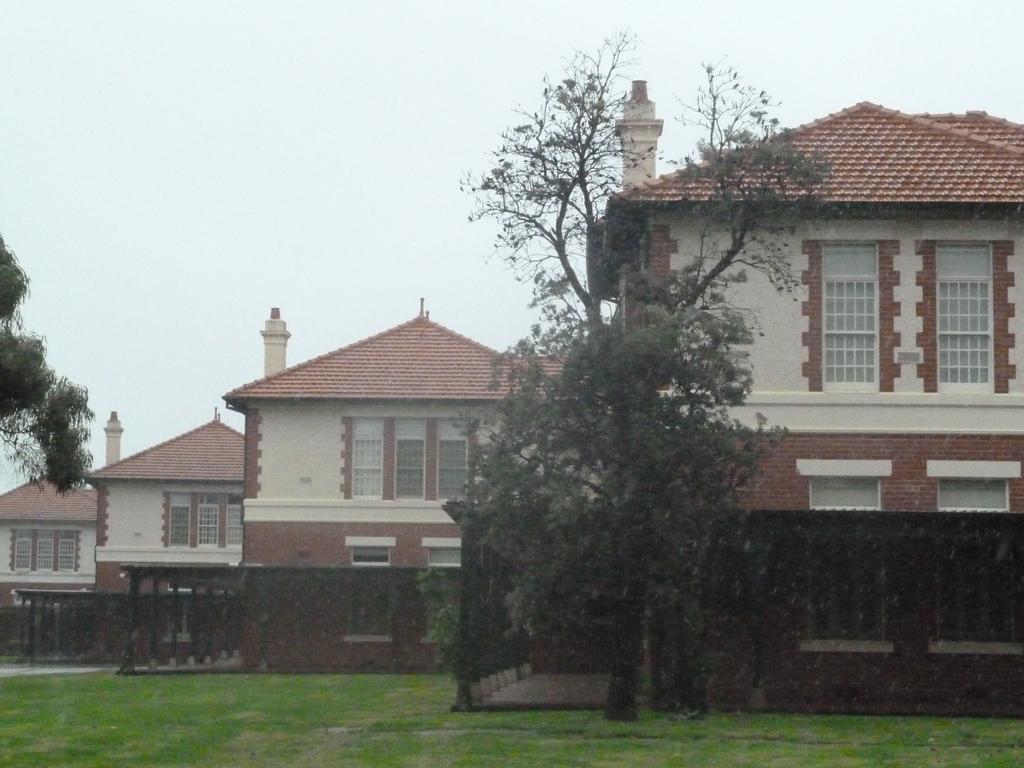Describe this image in one or two sentences. In this picture we can see trees, grass, buildings with windows and in the background we can see the sky. 